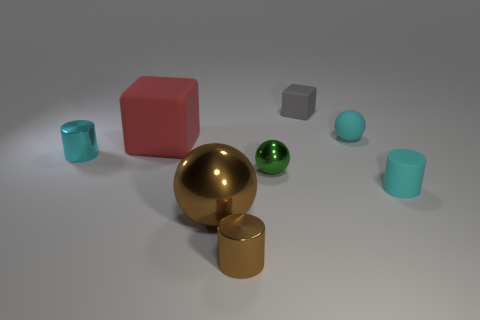Add 2 large gray cylinders. How many objects exist? 10 Subtract all cylinders. How many objects are left? 5 Subtract 0 blue blocks. How many objects are left? 8 Subtract all tiny balls. Subtract all tiny cyan things. How many objects are left? 3 Add 8 rubber blocks. How many rubber blocks are left? 10 Add 5 tiny blocks. How many tiny blocks exist? 6 